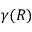<formula> <loc_0><loc_0><loc_500><loc_500>\gamma ( R )</formula> 